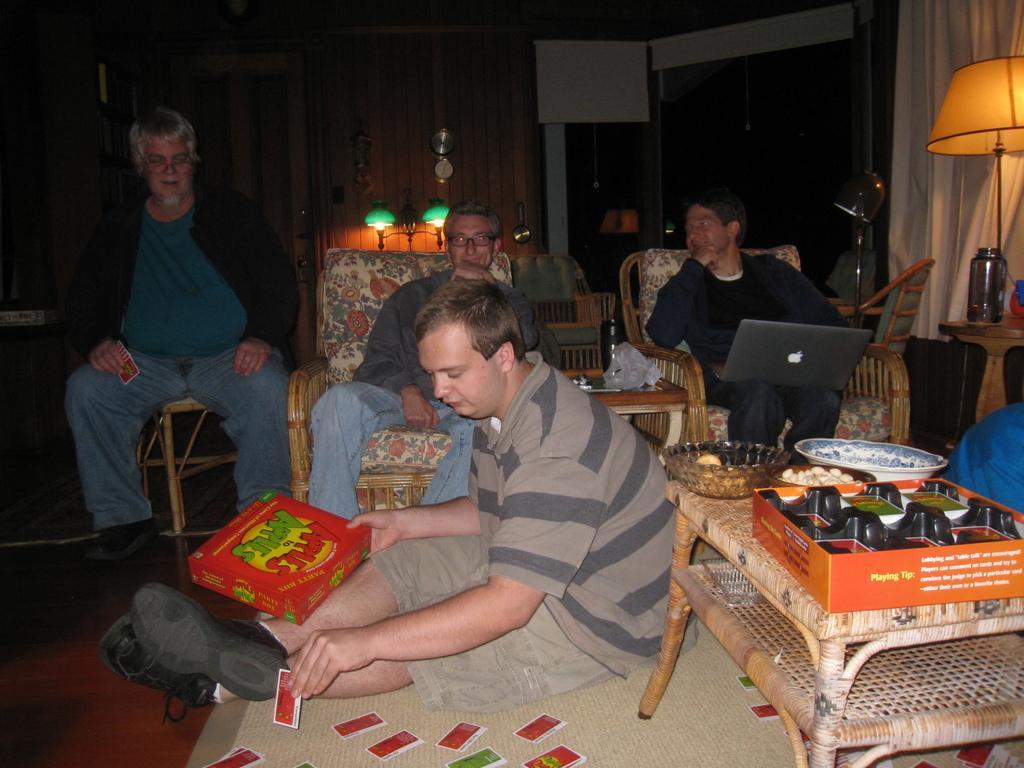How would you summarize this image in a sentence or two? In this image I can see few people were in the front I can see one is sitting on the floor and in the background few are sitting on chairs. On the right side of this image I can see a table and on it I can see few stuffs. I can also see a man is holding a red color box and few cards in the front and on the right side I can see a laptop, a lamp, a bottle, a light and a curtain. In the background I can see few more lights and a clock on the wall. 